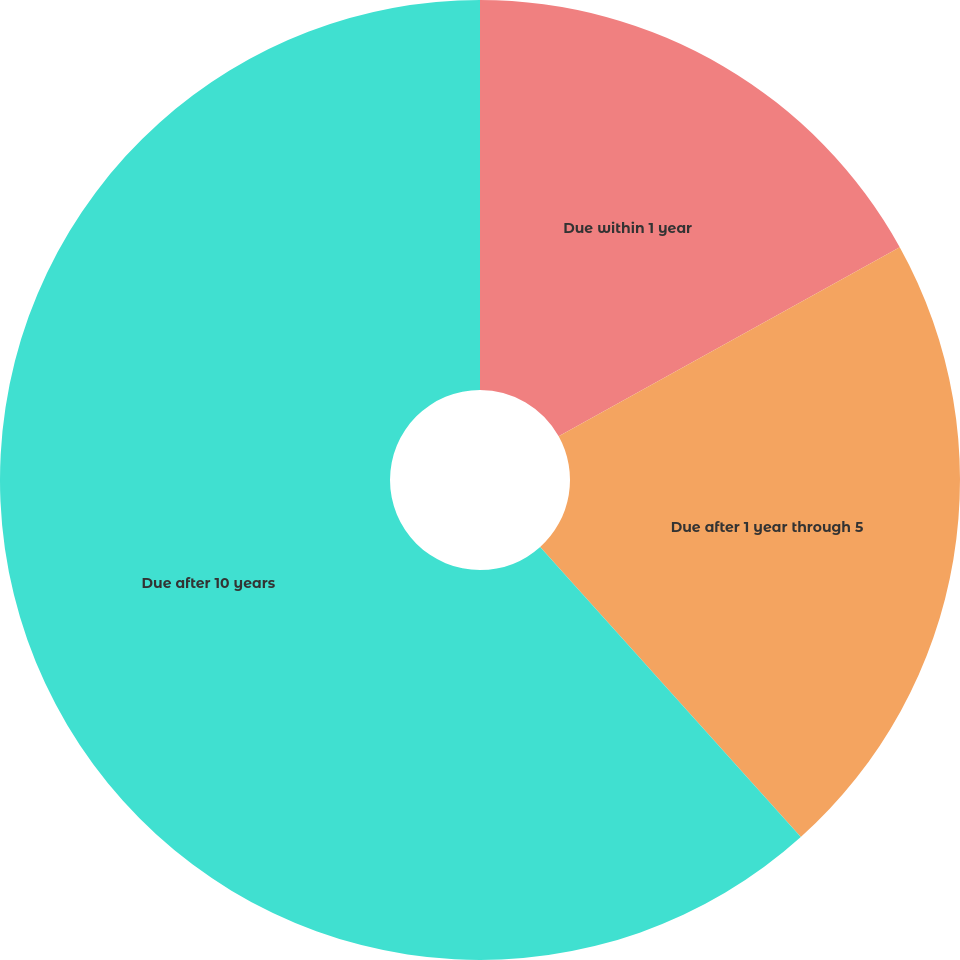Convert chart to OTSL. <chart><loc_0><loc_0><loc_500><loc_500><pie_chart><fcel>Due within 1 year<fcel>Due after 1 year through 5<fcel>Due after 10 years<nl><fcel>16.94%<fcel>21.41%<fcel>61.65%<nl></chart> 